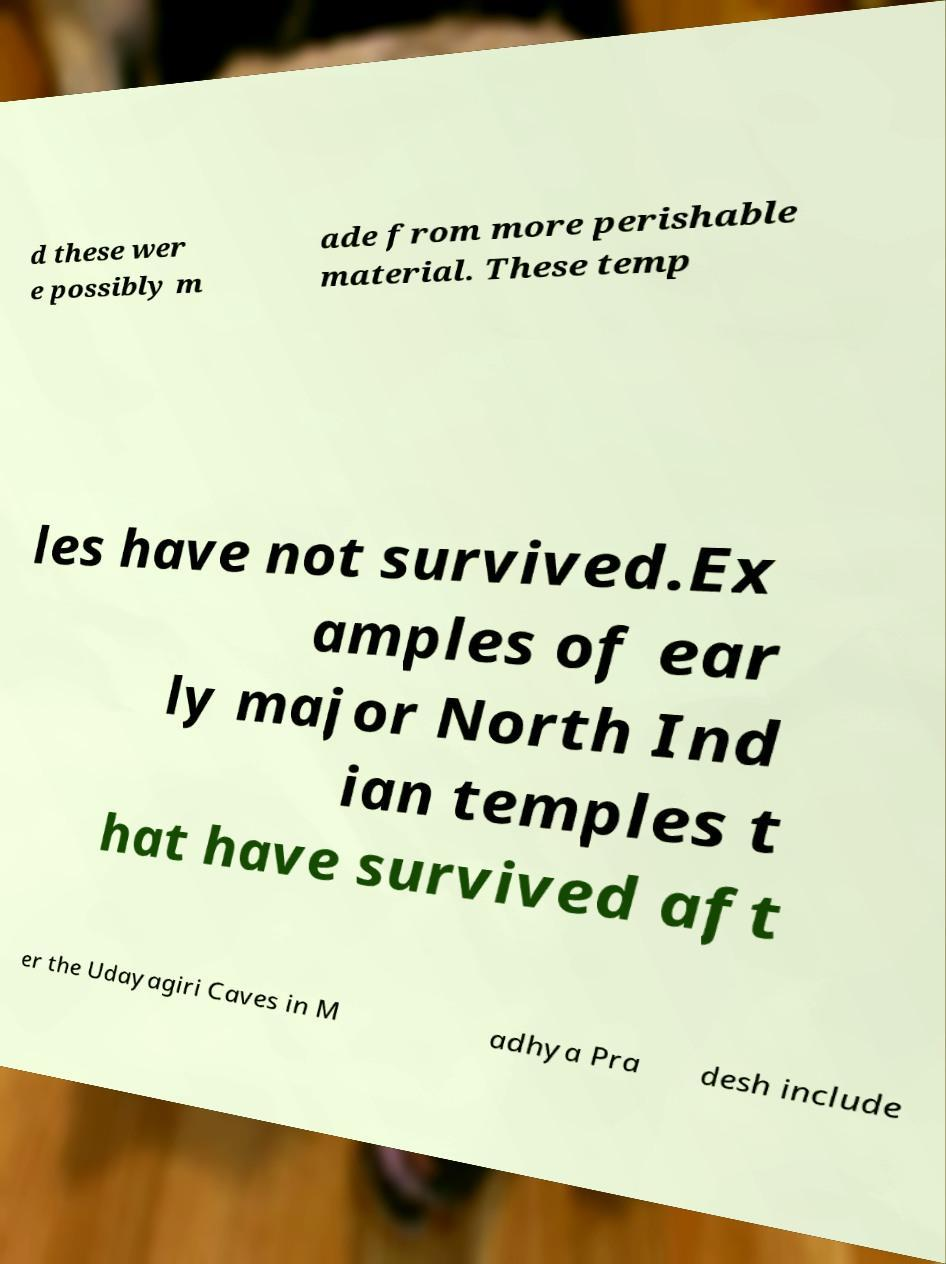Could you extract and type out the text from this image? d these wer e possibly m ade from more perishable material. These temp les have not survived.Ex amples of ear ly major North Ind ian temples t hat have survived aft er the Udayagiri Caves in M adhya Pra desh include 